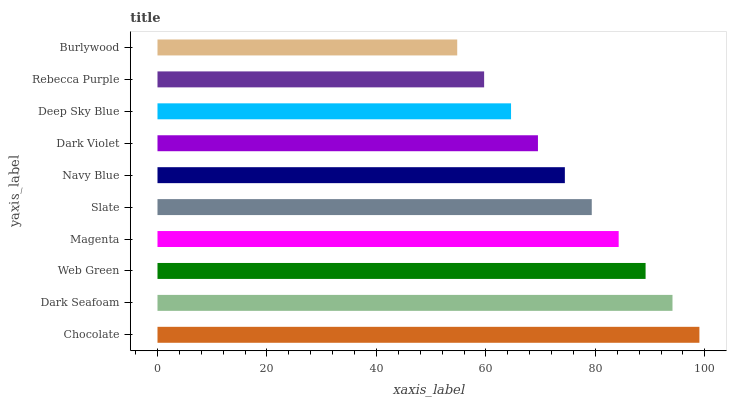Is Burlywood the minimum?
Answer yes or no. Yes. Is Chocolate the maximum?
Answer yes or no. Yes. Is Dark Seafoam the minimum?
Answer yes or no. No. Is Dark Seafoam the maximum?
Answer yes or no. No. Is Chocolate greater than Dark Seafoam?
Answer yes or no. Yes. Is Dark Seafoam less than Chocolate?
Answer yes or no. Yes. Is Dark Seafoam greater than Chocolate?
Answer yes or no. No. Is Chocolate less than Dark Seafoam?
Answer yes or no. No. Is Slate the high median?
Answer yes or no. Yes. Is Navy Blue the low median?
Answer yes or no. Yes. Is Web Green the high median?
Answer yes or no. No. Is Dark Violet the low median?
Answer yes or no. No. 